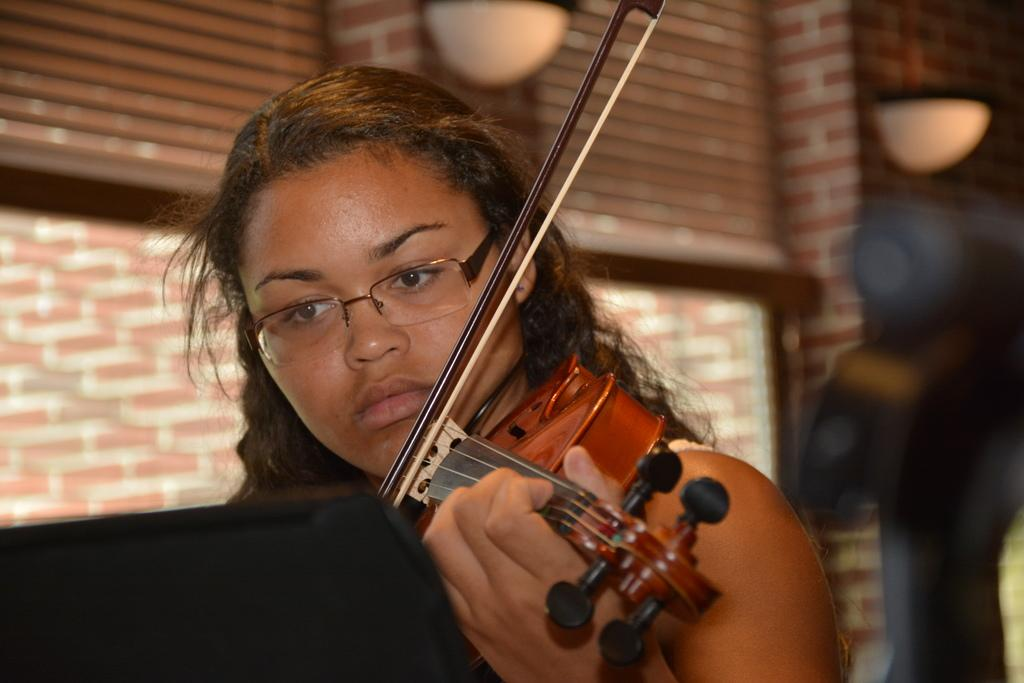Who is the main subject in the image? There is a lady in the center of the image. What is the lady doing in the image? The lady is playing a violin. What can be seen in the background of the image? There is a window and a brick wall in the background of the image. How does the lady express her hatred for the violin in the image? There is no indication of hatred in the image; the lady is playing the violin, which suggests she enjoys it. 